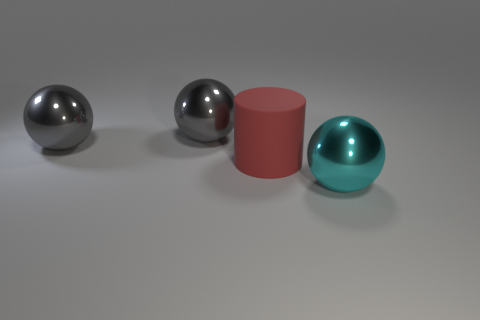How many big red rubber things are there?
Provide a succinct answer. 1. What number of other objects are there of the same size as the matte thing?
Your response must be concise. 3. There is a matte cylinder; how many big gray spheres are in front of it?
Provide a succinct answer. 0. What is the size of the cyan thing?
Offer a terse response. Large. Are there any large spheres made of the same material as the cyan object?
Make the answer very short. Yes. Is the number of gray metal objects that are on the right side of the rubber cylinder less than the number of cyan spheres?
Give a very brief answer. Yes. There is a sphere to the right of the cylinder; does it have the same size as the big cylinder?
Offer a terse response. Yes. How many gray shiny objects are the same shape as the large cyan metallic thing?
Provide a succinct answer. 2. Are there the same number of big red matte cylinders that are in front of the large red rubber object and red cubes?
Provide a succinct answer. Yes. How many objects are either big metal cylinders or big red rubber cylinders?
Offer a very short reply. 1. 